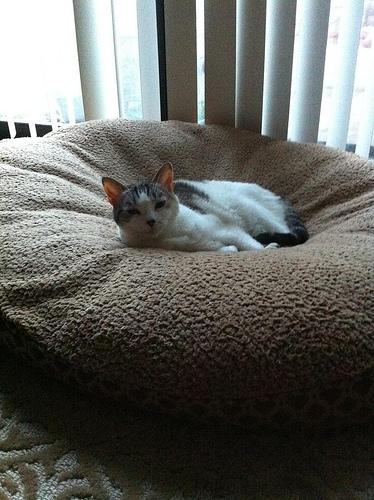Question: why is the cat in bed during the day?
Choices:
A. Likes it.
B. Sick.
C. Cat nap time.
D. Has bed to self.
Answer with the letter. Answer: C Question: what color is the pet bed?
Choices:
A. Checkered red.
B. Striped blue.
C. Pink.
D. Tan.
Answer with the letter. Answer: D Question: what is below the pet bed?
Choices:
A. Textured carpet.
B. Wood floor.
C. Marble floor.
D. Pillow.
Answer with the letter. Answer: A Question: when was the picture taken?
Choices:
A. Daytime.
B. Midnight.
C. 8:00.
D. Dawn.
Answer with the letter. Answer: A 